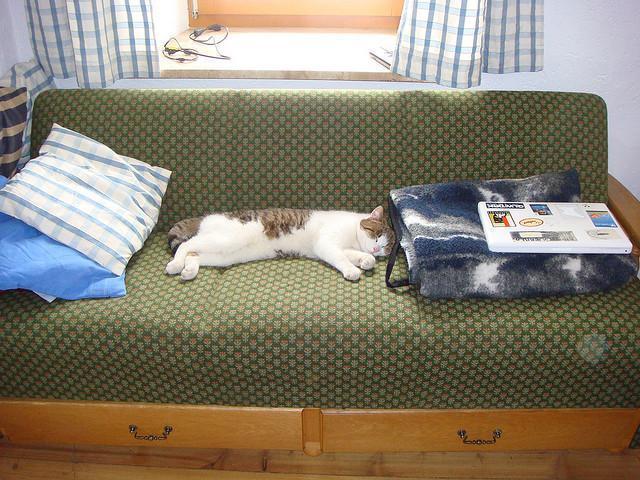How many books are visible?
Give a very brief answer. 1. 